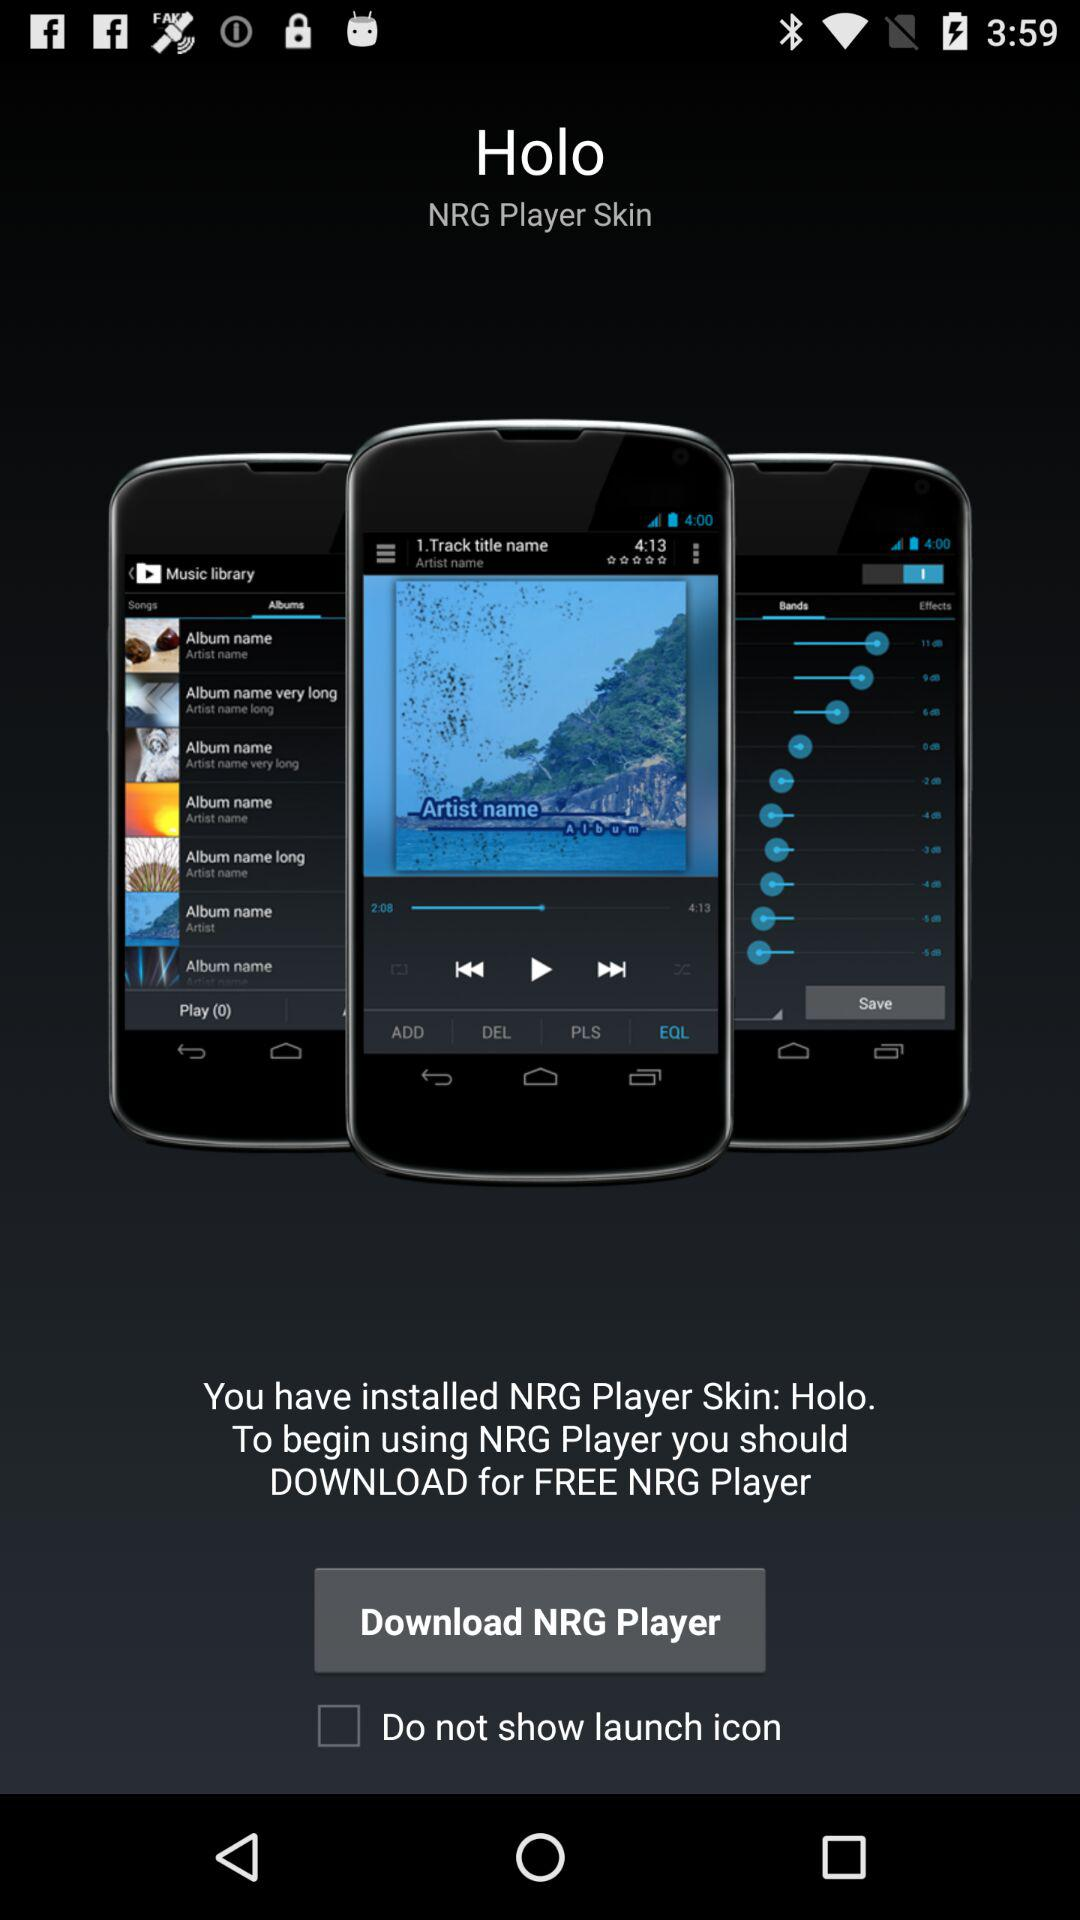What is the application name? The application names are "NRG Player Skin: Holo" and "NRG Player". 